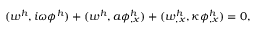Convert formula to latex. <formula><loc_0><loc_0><loc_500><loc_500>( w ^ { h } , i \omega \phi ^ { h } ) + ( w ^ { h } , a \phi _ { , x } ^ { h } ) + ( w _ { , x } ^ { h } , \kappa \phi _ { , x } ^ { h } ) = 0 ,</formula> 